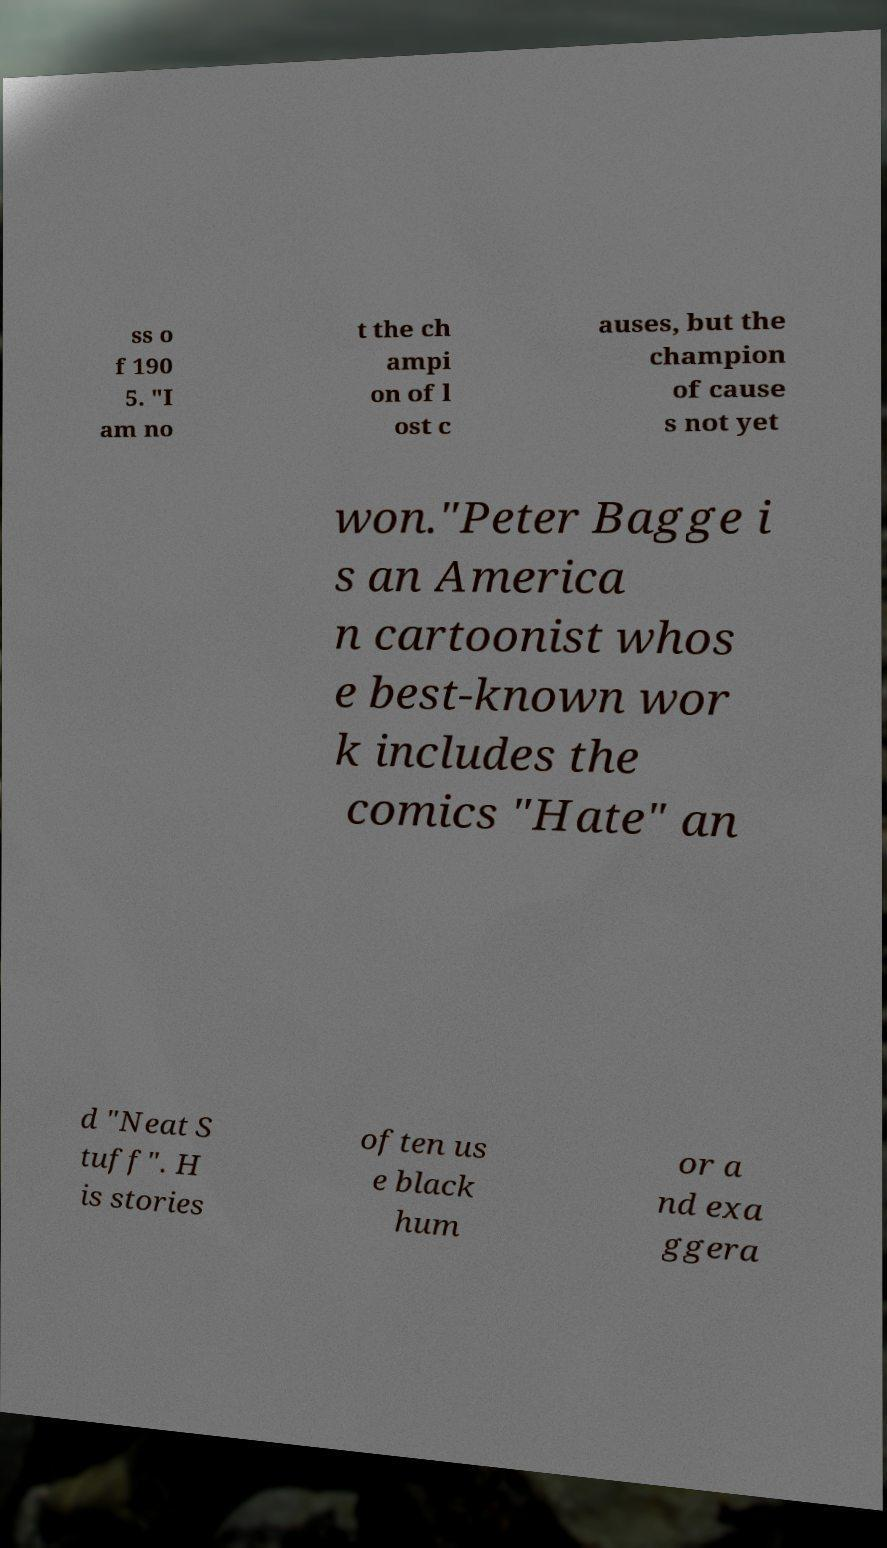There's text embedded in this image that I need extracted. Can you transcribe it verbatim? ss o f 190 5. "I am no t the ch ampi on of l ost c auses, but the champion of cause s not yet won."Peter Bagge i s an America n cartoonist whos e best-known wor k includes the comics "Hate" an d "Neat S tuff". H is stories often us e black hum or a nd exa ggera 